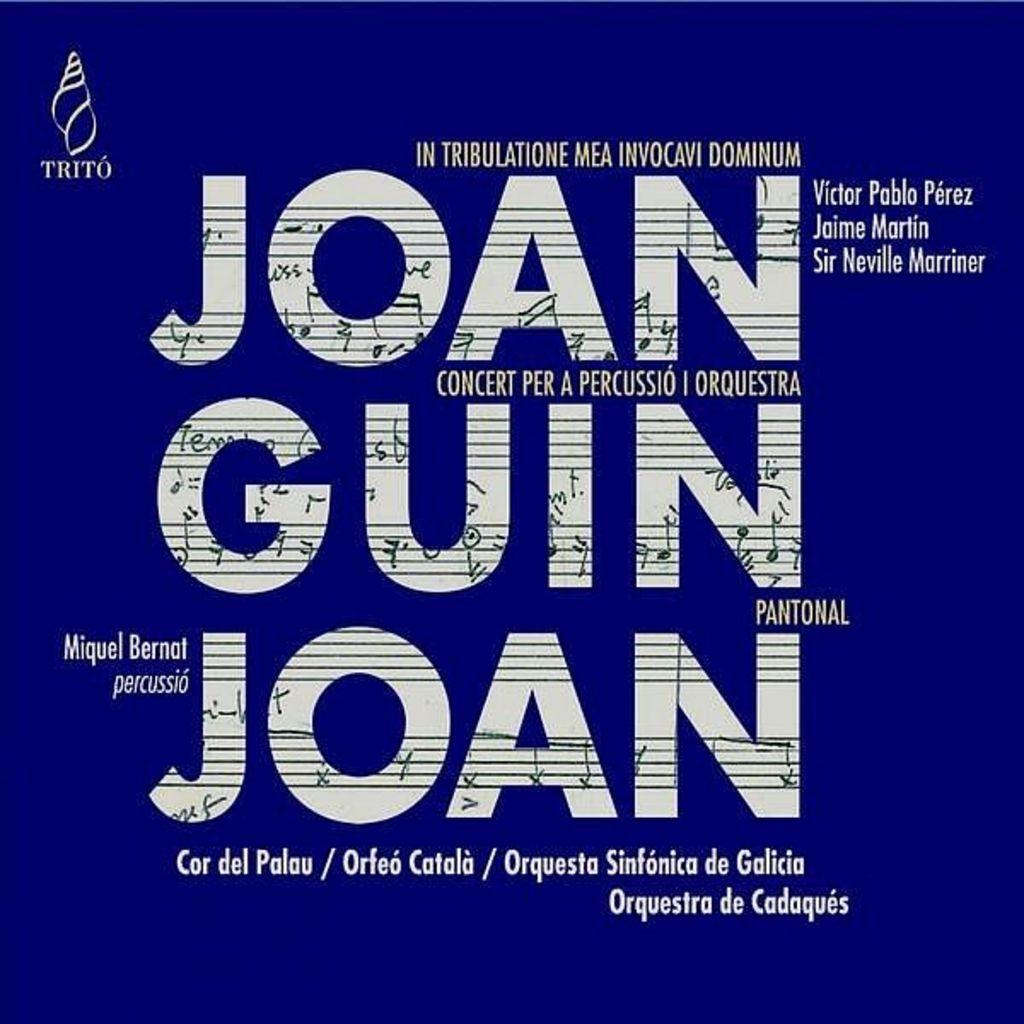What color is the poster in the image? The poster is blue. What can be found on the poster besides its color? There is text on the poster. What type of poison is mentioned on the poster? There is no mention of poison on the poster; it only contains text and is blue in color. 